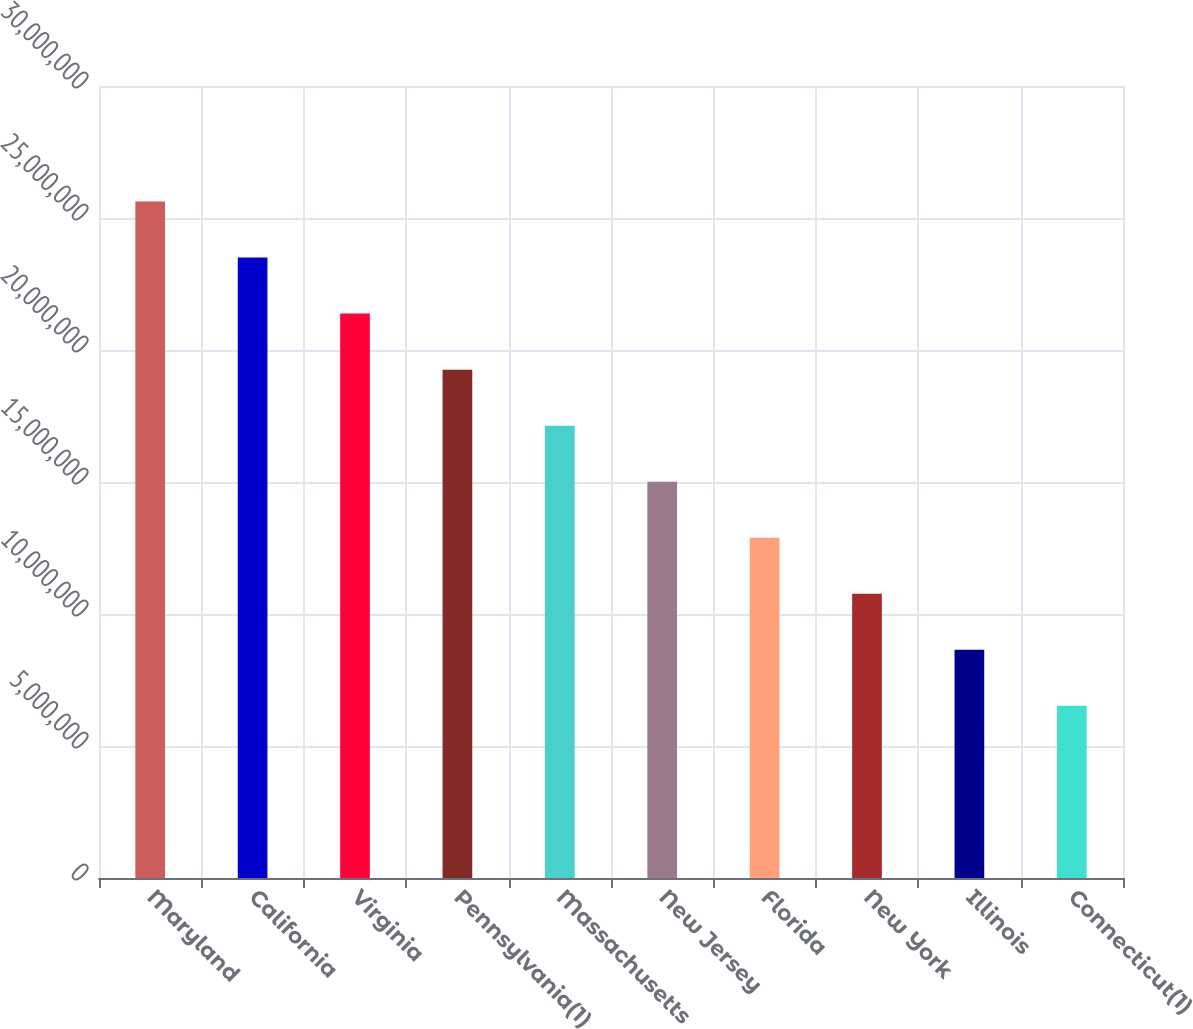Convert chart to OTSL. <chart><loc_0><loc_0><loc_500><loc_500><bar_chart><fcel>Maryland<fcel>California<fcel>Virginia<fcel>Pennsylvania(1)<fcel>Massachusetts<fcel>New Jersey<fcel>Florida<fcel>New York<fcel>Illinois<fcel>Connecticut(1)<nl><fcel>2.56242e+07<fcel>2.35016e+07<fcel>2.1379e+07<fcel>1.92564e+07<fcel>1.71338e+07<fcel>1.50112e+07<fcel>1.28886e+07<fcel>1.0766e+07<fcel>8.6434e+06<fcel>6.5208e+06<nl></chart> 